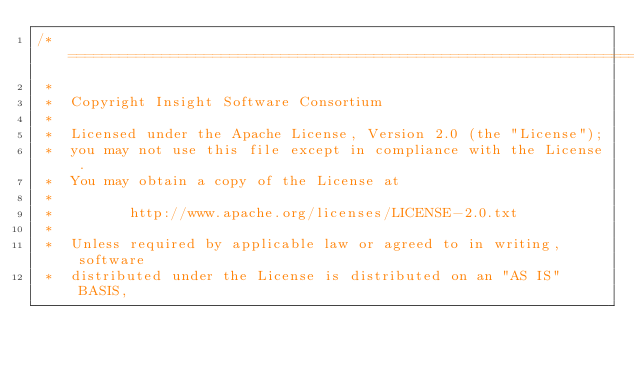<code> <loc_0><loc_0><loc_500><loc_500><_C_>/*=========================================================================
 *
 *  Copyright Insight Software Consortium
 *
 *  Licensed under the Apache License, Version 2.0 (the "License");
 *  you may not use this file except in compliance with the License.
 *  You may obtain a copy of the License at
 *
 *         http://www.apache.org/licenses/LICENSE-2.0.txt
 *
 *  Unless required by applicable law or agreed to in writing, software
 *  distributed under the License is distributed on an "AS IS" BASIS,</code> 